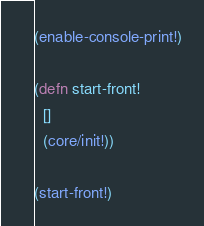<code> <loc_0><loc_0><loc_500><loc_500><_Clojure_>(enable-console-print!)

(defn start-front!
  []
  (core/init!))

(start-front!)
</code> 